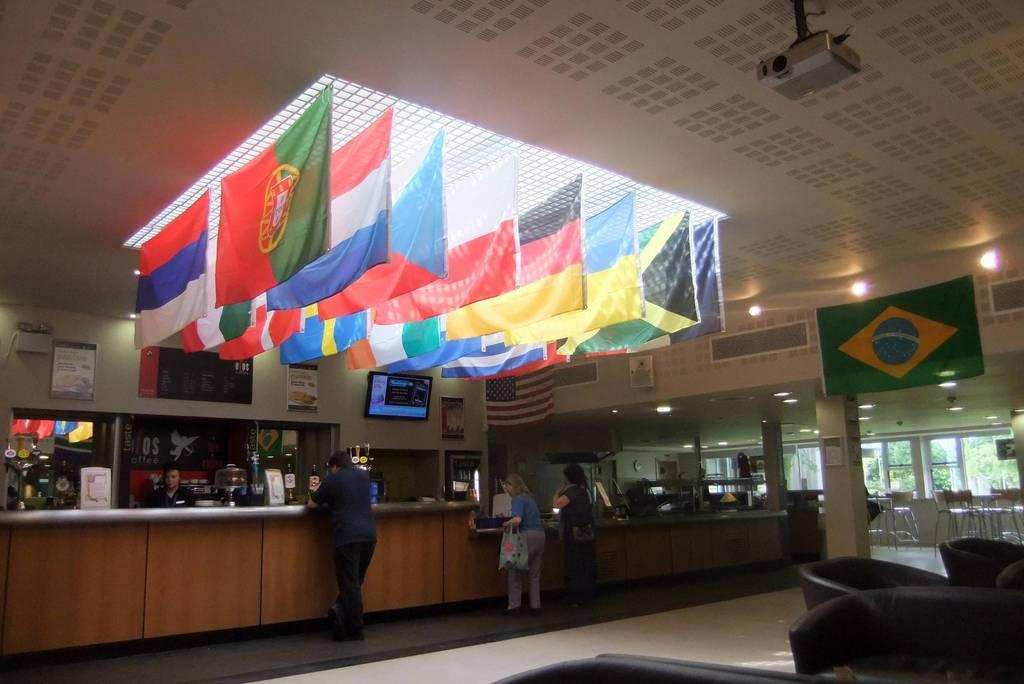How many people are present in the image? There are three persons standing in the image. What is the surface on which the persons are standing? The persons are standing on the floor. What type of furniture can be seen in the image? There are chairs in the image. What architectural feature is present in the image? There is a pillar in the image. What decorative elements are visible in the image? There are flags and lights in the image. What type of verse is being recited by the persons in the image? There is no indication in the image that the persons are reciting any verse, so it cannot be determined from the picture. 